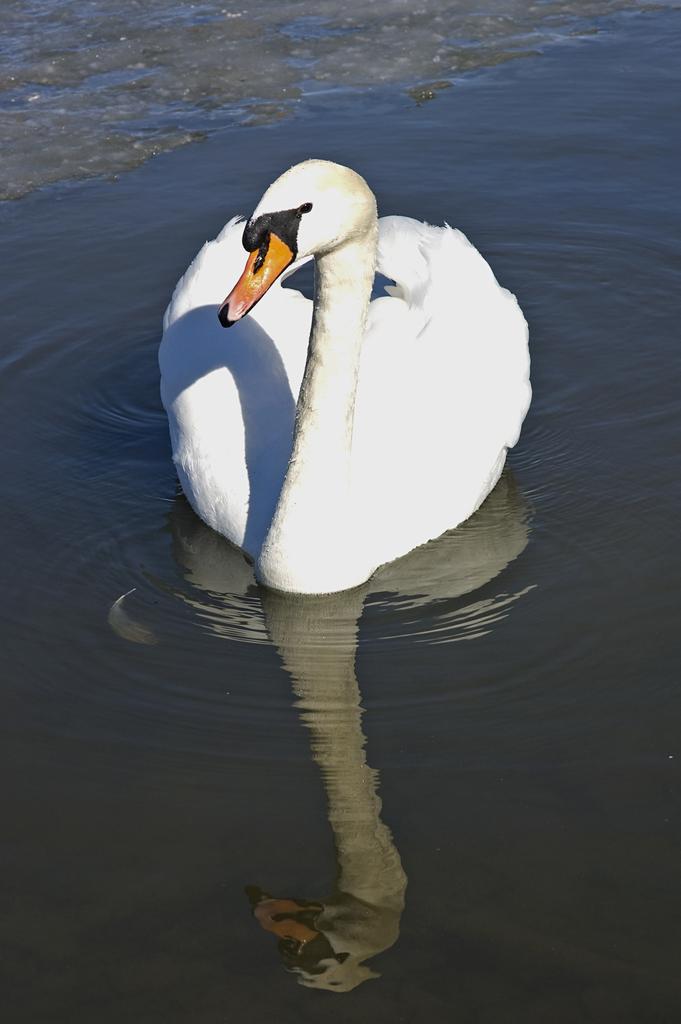In one or two sentences, can you explain what this image depicts? In this image, we can see a white swan on the water. 